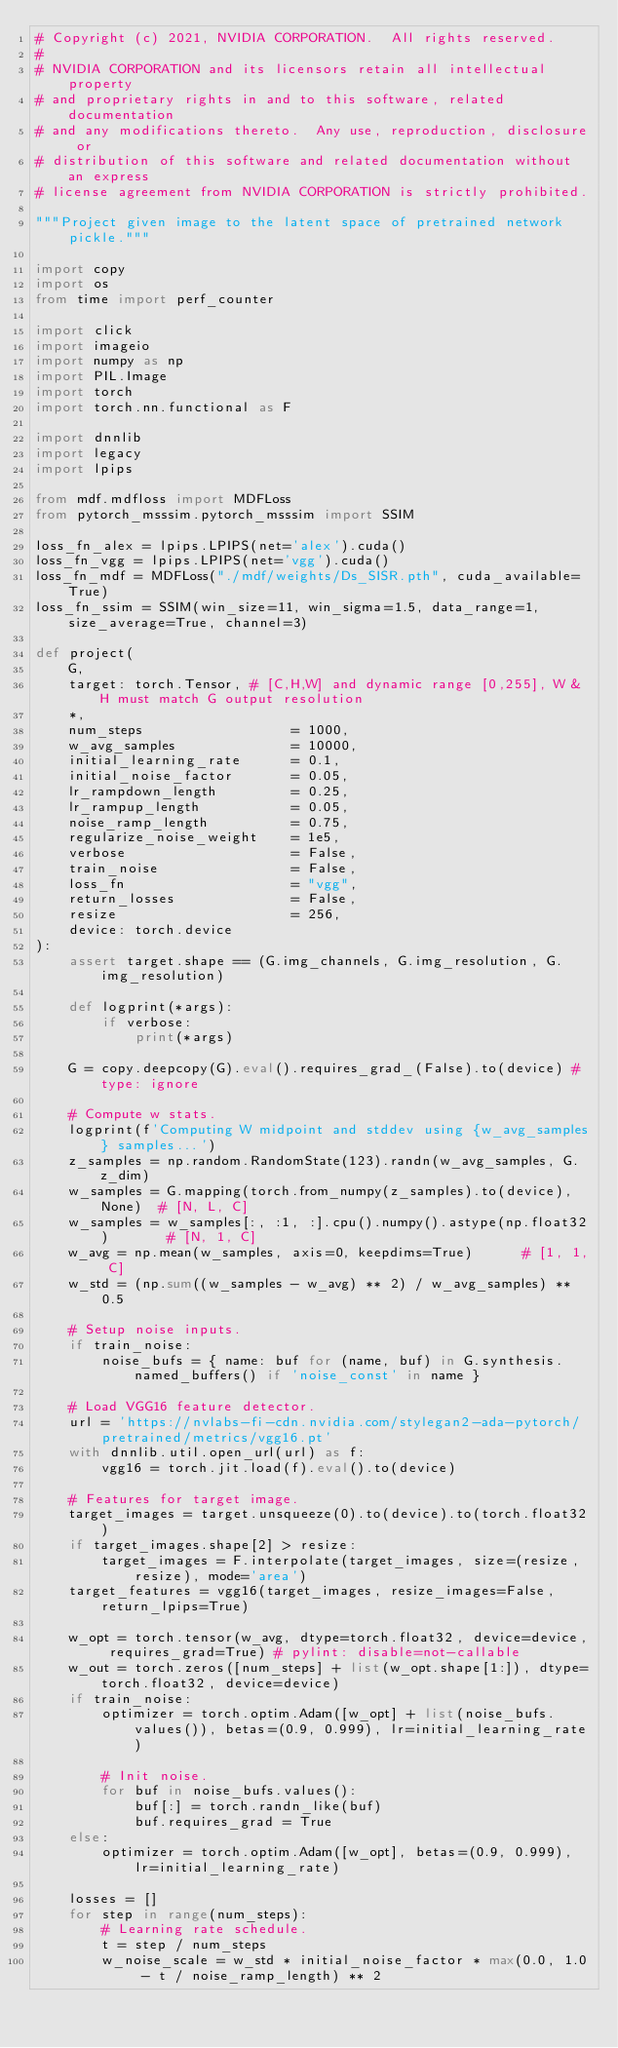Convert code to text. <code><loc_0><loc_0><loc_500><loc_500><_Python_># Copyright (c) 2021, NVIDIA CORPORATION.  All rights reserved.
#
# NVIDIA CORPORATION and its licensors retain all intellectual property
# and proprietary rights in and to this software, related documentation
# and any modifications thereto.  Any use, reproduction, disclosure or
# distribution of this software and related documentation without an express
# license agreement from NVIDIA CORPORATION is strictly prohibited.

"""Project given image to the latent space of pretrained network pickle."""

import copy
import os
from time import perf_counter

import click
import imageio
import numpy as np
import PIL.Image
import torch
import torch.nn.functional as F

import dnnlib
import legacy
import lpips

from mdf.mdfloss import MDFLoss
from pytorch_msssim.pytorch_msssim import SSIM

loss_fn_alex = lpips.LPIPS(net='alex').cuda()
loss_fn_vgg = lpips.LPIPS(net='vgg').cuda()
loss_fn_mdf = MDFLoss("./mdf/weights/Ds_SISR.pth", cuda_available=True)
loss_fn_ssim = SSIM(win_size=11, win_sigma=1.5, data_range=1, size_average=True, channel=3)

def project(
    G,
    target: torch.Tensor, # [C,H,W] and dynamic range [0,255], W & H must match G output resolution
    *,
    num_steps                  = 1000,
    w_avg_samples              = 10000,
    initial_learning_rate      = 0.1,
    initial_noise_factor       = 0.05,
    lr_rampdown_length         = 0.25,
    lr_rampup_length           = 0.05,
    noise_ramp_length          = 0.75,
    regularize_noise_weight    = 1e5,
    verbose                    = False,
    train_noise                = False,
    loss_fn                    = "vgg",
    return_losses              = False,
    resize                     = 256,
    device: torch.device
):
    assert target.shape == (G.img_channels, G.img_resolution, G.img_resolution)

    def logprint(*args):
        if verbose:
            print(*args)

    G = copy.deepcopy(G).eval().requires_grad_(False).to(device) # type: ignore

    # Compute w stats.
    logprint(f'Computing W midpoint and stddev using {w_avg_samples} samples...')
    z_samples = np.random.RandomState(123).randn(w_avg_samples, G.z_dim)
    w_samples = G.mapping(torch.from_numpy(z_samples).to(device), None)  # [N, L, C]
    w_samples = w_samples[:, :1, :].cpu().numpy().astype(np.float32)       # [N, 1, C]
    w_avg = np.mean(w_samples, axis=0, keepdims=True)      # [1, 1, C]
    w_std = (np.sum((w_samples - w_avg) ** 2) / w_avg_samples) ** 0.5

    # Setup noise inputs.
    if train_noise:
        noise_bufs = { name: buf for (name, buf) in G.synthesis.named_buffers() if 'noise_const' in name }

    # Load VGG16 feature detector.
    url = 'https://nvlabs-fi-cdn.nvidia.com/stylegan2-ada-pytorch/pretrained/metrics/vgg16.pt'
    with dnnlib.util.open_url(url) as f:
        vgg16 = torch.jit.load(f).eval().to(device)

    # Features for target image.
    target_images = target.unsqueeze(0).to(device).to(torch.float32)
    if target_images.shape[2] > resize:
        target_images = F.interpolate(target_images, size=(resize, resize), mode='area')
    target_features = vgg16(target_images, resize_images=False, return_lpips=True)

    w_opt = torch.tensor(w_avg, dtype=torch.float32, device=device, requires_grad=True) # pylint: disable=not-callable
    w_out = torch.zeros([num_steps] + list(w_opt.shape[1:]), dtype=torch.float32, device=device)
    if train_noise:
        optimizer = torch.optim.Adam([w_opt] + list(noise_bufs.values()), betas=(0.9, 0.999), lr=initial_learning_rate)

        # Init noise.
        for buf in noise_bufs.values():
            buf[:] = torch.randn_like(buf)
            buf.requires_grad = True
    else:
        optimizer = torch.optim.Adam([w_opt], betas=(0.9, 0.999), lr=initial_learning_rate)

    losses = []
    for step in range(num_steps):
        # Learning rate schedule.
        t = step / num_steps
        w_noise_scale = w_std * initial_noise_factor * max(0.0, 1.0 - t / noise_ramp_length) ** 2</code> 